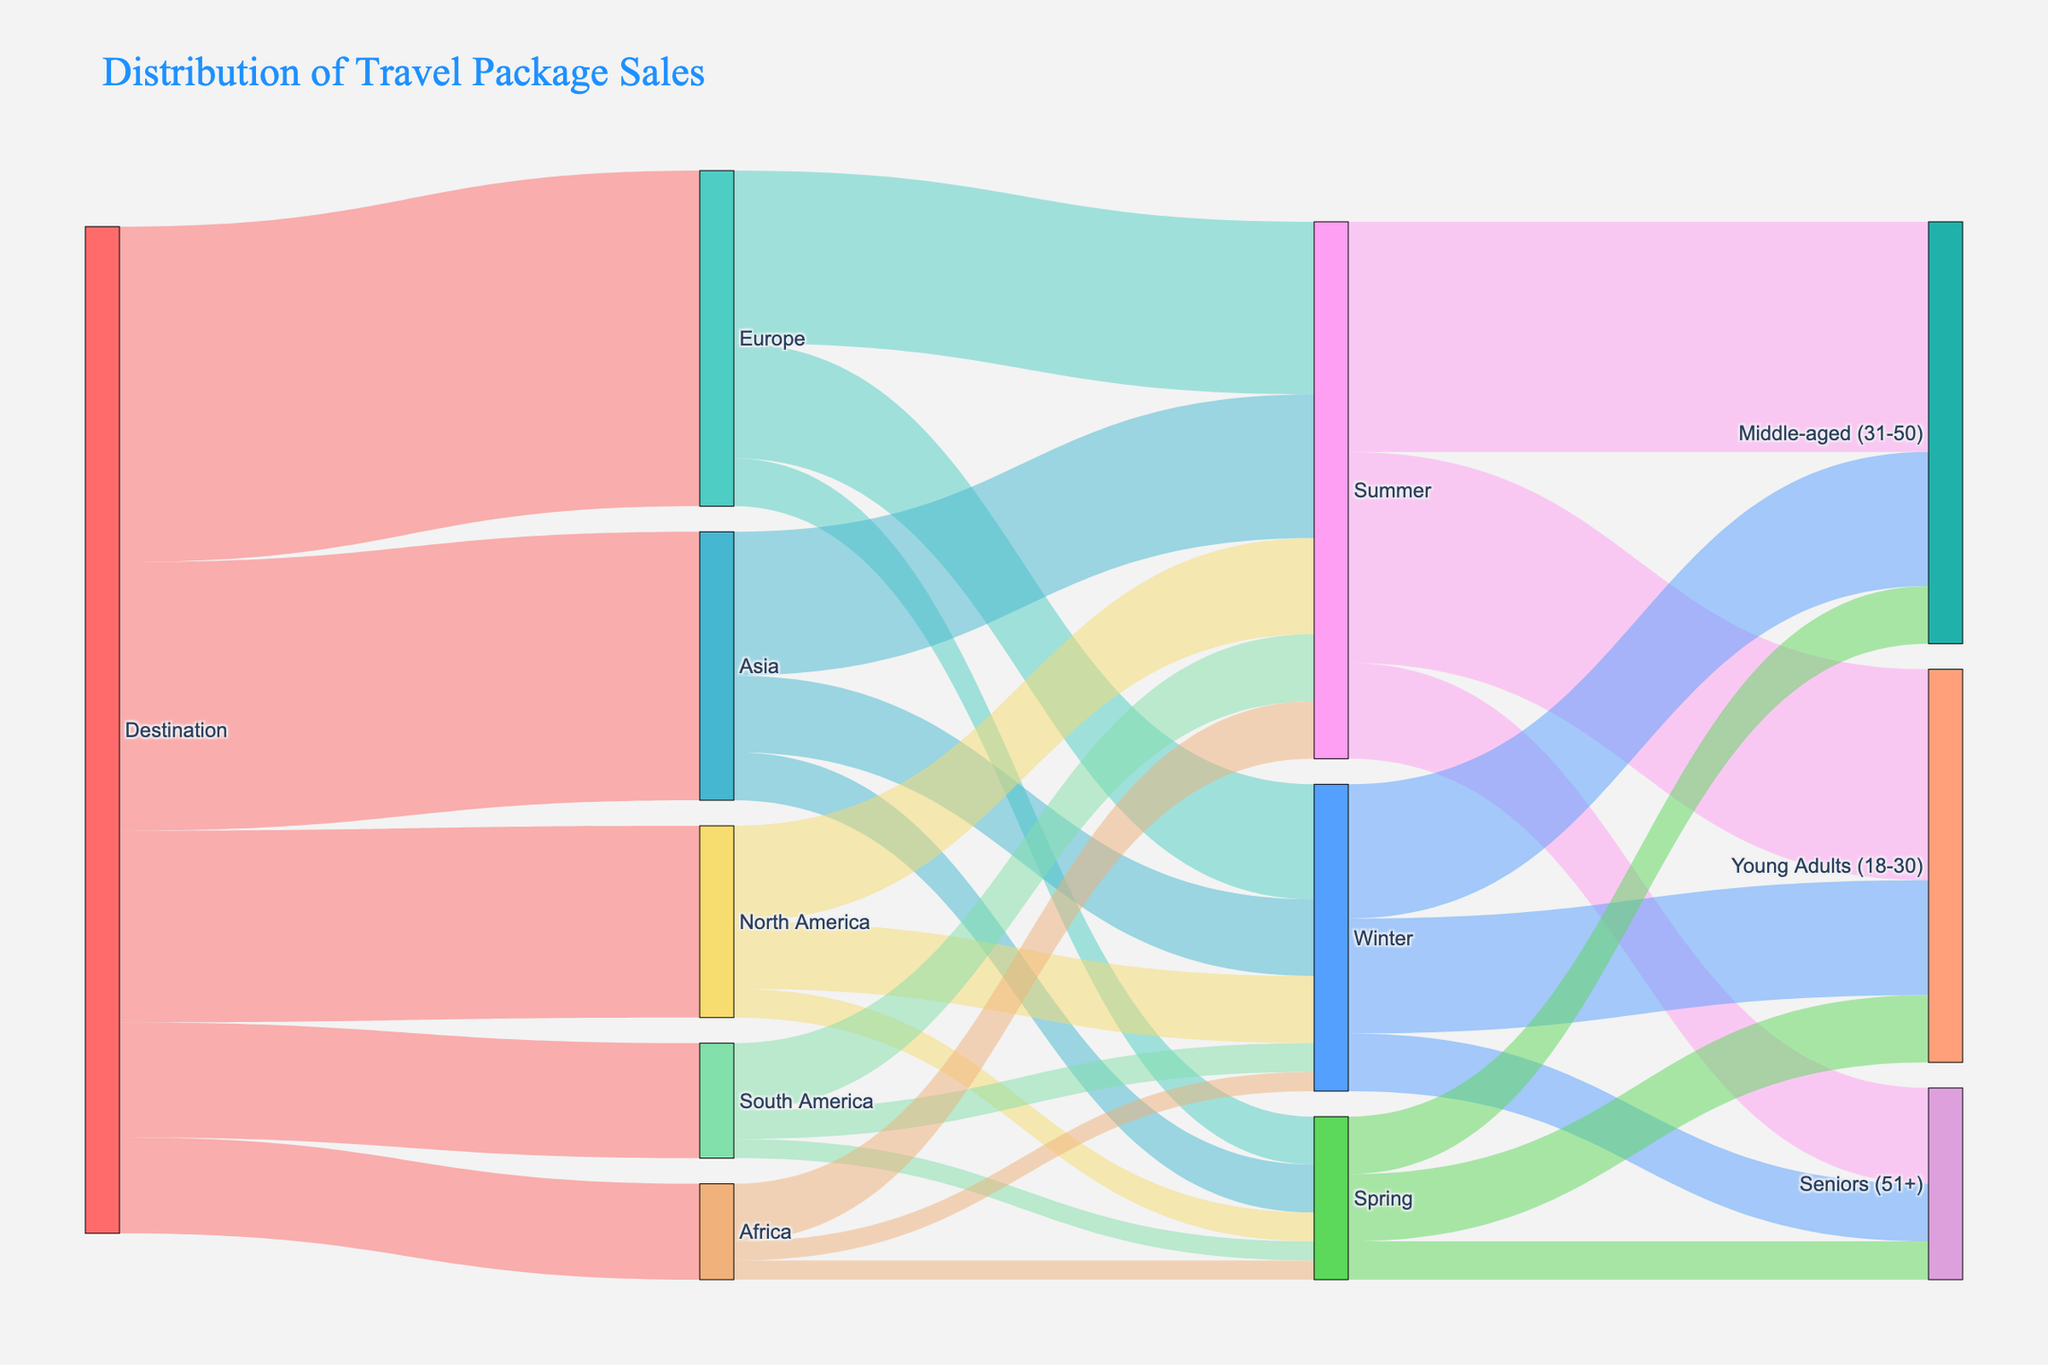What is the title of the Sankey Diagram? The title of the diagram is usually located at the top and is typically bolded or has a larger font size compared to other text elements. In this case, it is clearly stated at the top of the diagram.
Answer: Distribution of Travel Package Sales How many destinations are included in the travel package sales data? Each destination is represented by a label connected to "Destination" at the beginning of the Sankey diagram. Reading directly from the chart, the number of distinct destinations are labeled.
Answer: 5 Which season has the highest number of travel packages sold for Europe? Following the links from "Europe" to the different seasons, we can see that the thickness of the lines, corresponding to values, is largest for one particular season. Here, the line to "Summer" is the thickest.
Answer: Summer What is the total number of travel packages sold in Winter across all destinations? Observing the "Winter" node and summing the values of all incoming links from different destinations, we can compute the total: Europe (120) + Asia (80) + North America (70) + South America (30) + Africa (20) = 320.
Answer: 320 Which customer age group purchases the most travel packages in Summer? By tracing the lines from "Summer" to the different age groups, the thickness of the lines indicates number of packages sold. The thickest line connects "Summer" to "Middle-aged (31-50)".
Answer: Middle-aged (31-50) How many more travel packages are sold to Europe in Summer compared to Winter? Look at the values for Europe in Summer and Winter, which are 180 and 120, respectively. The difference is computed by subtracting the winter value from the summer value: 180 - 120.
Answer: 60 Which destination has the least travel packages sold and what is the total number sold? By inspecting the links from "Destination" to the various regions, the thinnest line corresponds to the fewest packages sold. Africa has the thinnest line with a value of 100.
Answer: Africa, 100 How many total travel packages are sold to customers aged 51+ during the Spring season? Look at the links from "Spring" to the age groups and locate the value for "Seniors (51+)". It is directly labeled as 40.
Answer: 40 Which season sees the least travel package sales in North America and what is the number of sales? Follow the links from "North America" to each season and find the one with the thinnest line. "Spring" has the smallest value, which is 30.
Answer: Spring, 30 In which season do the most young adults (18-30) purchase travel packages? Check the values of the links from each season to "Young Adults (18-30)". The highest value is from "Summer" with 220.
Answer: Summer 